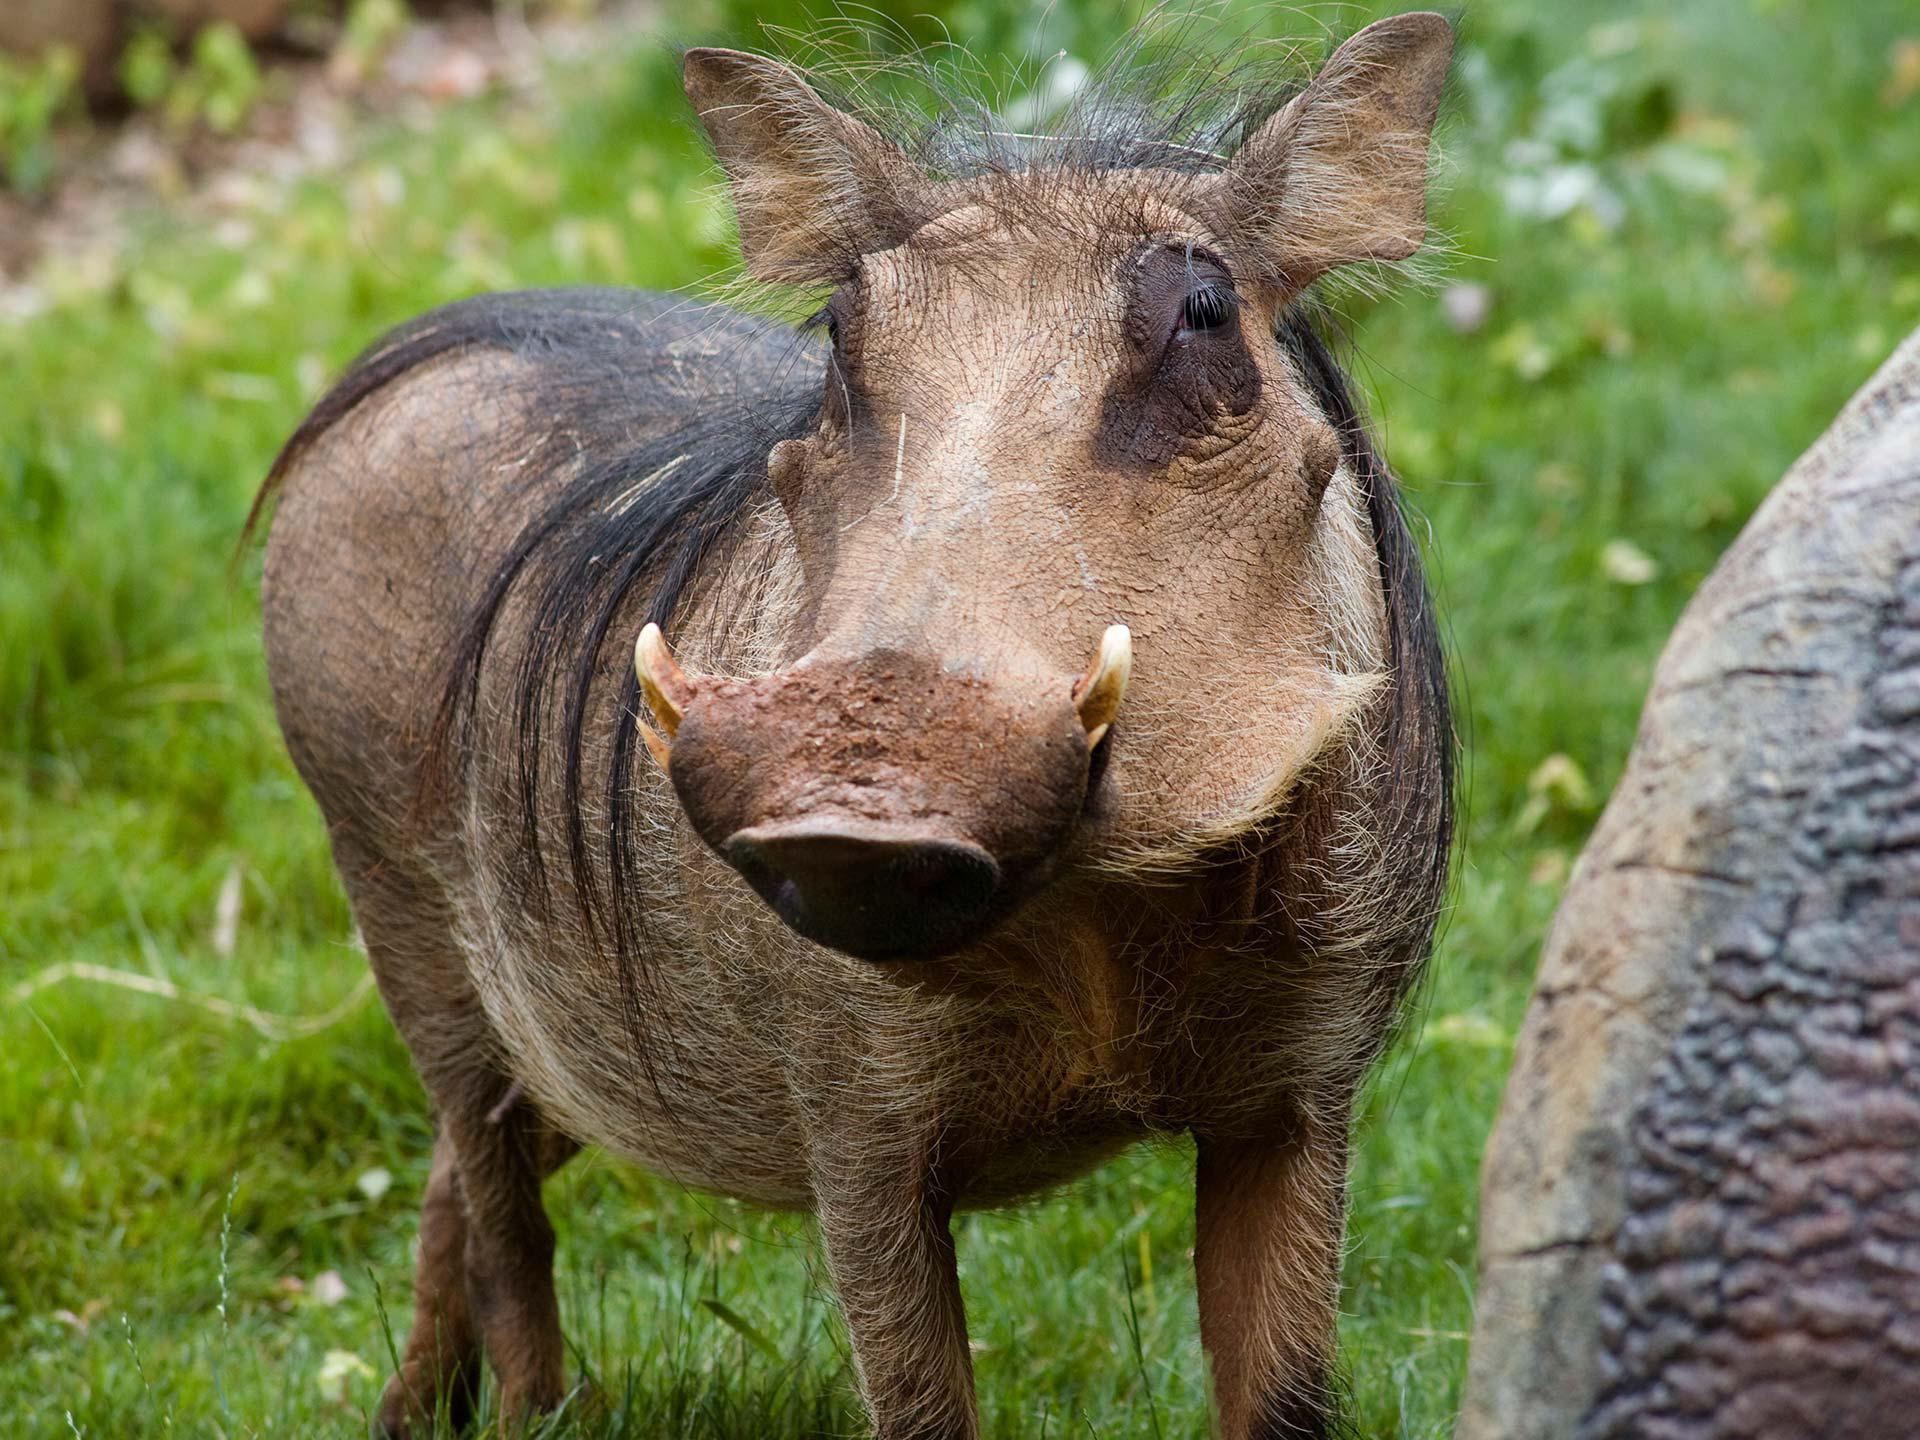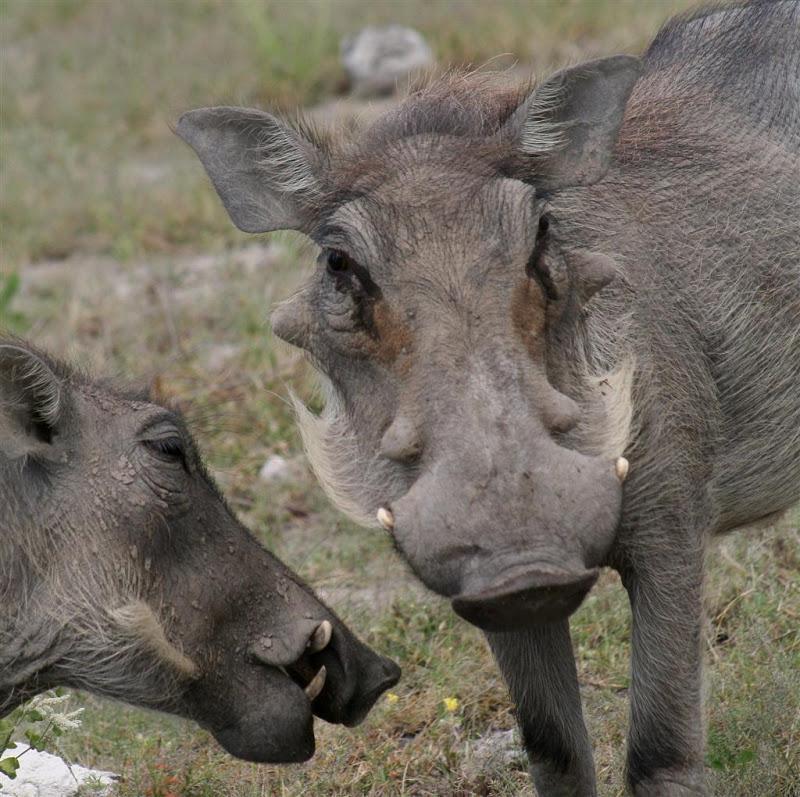The first image is the image on the left, the second image is the image on the right. For the images displayed, is the sentence "At least one image contains more than one warthog." factually correct? Answer yes or no. Yes. 